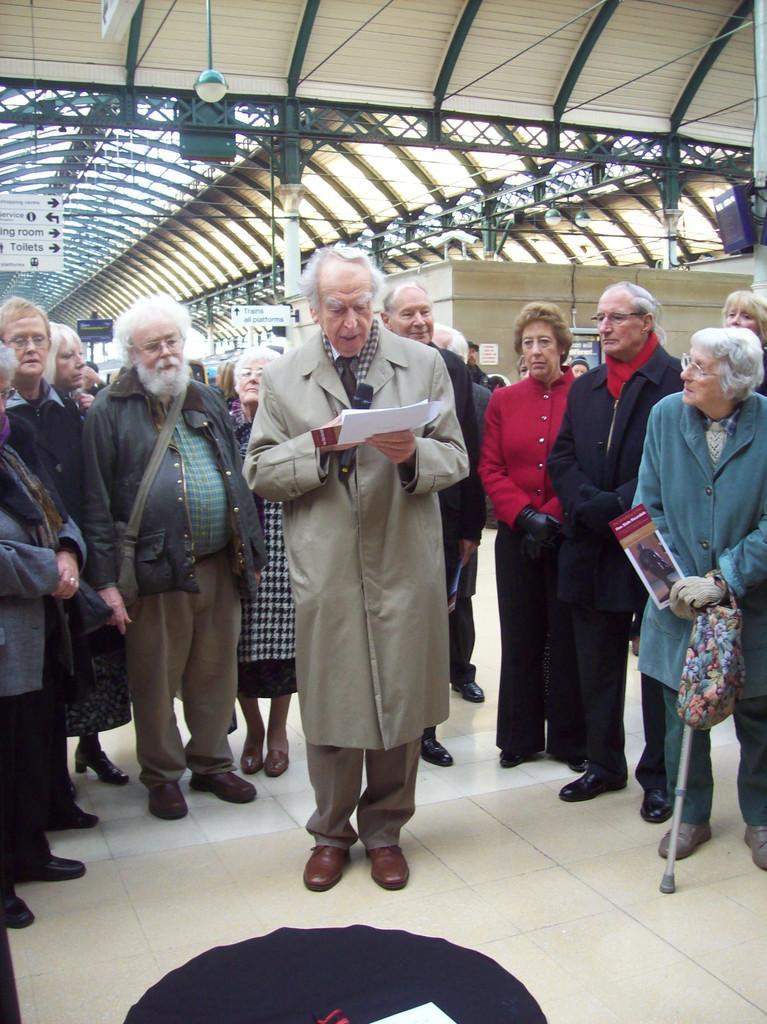Describe this image in one or two sentences. In this image I can see there are few persons standing on the floor and I can see a person holding a paper standing in the middle and I can see the roof at the top 